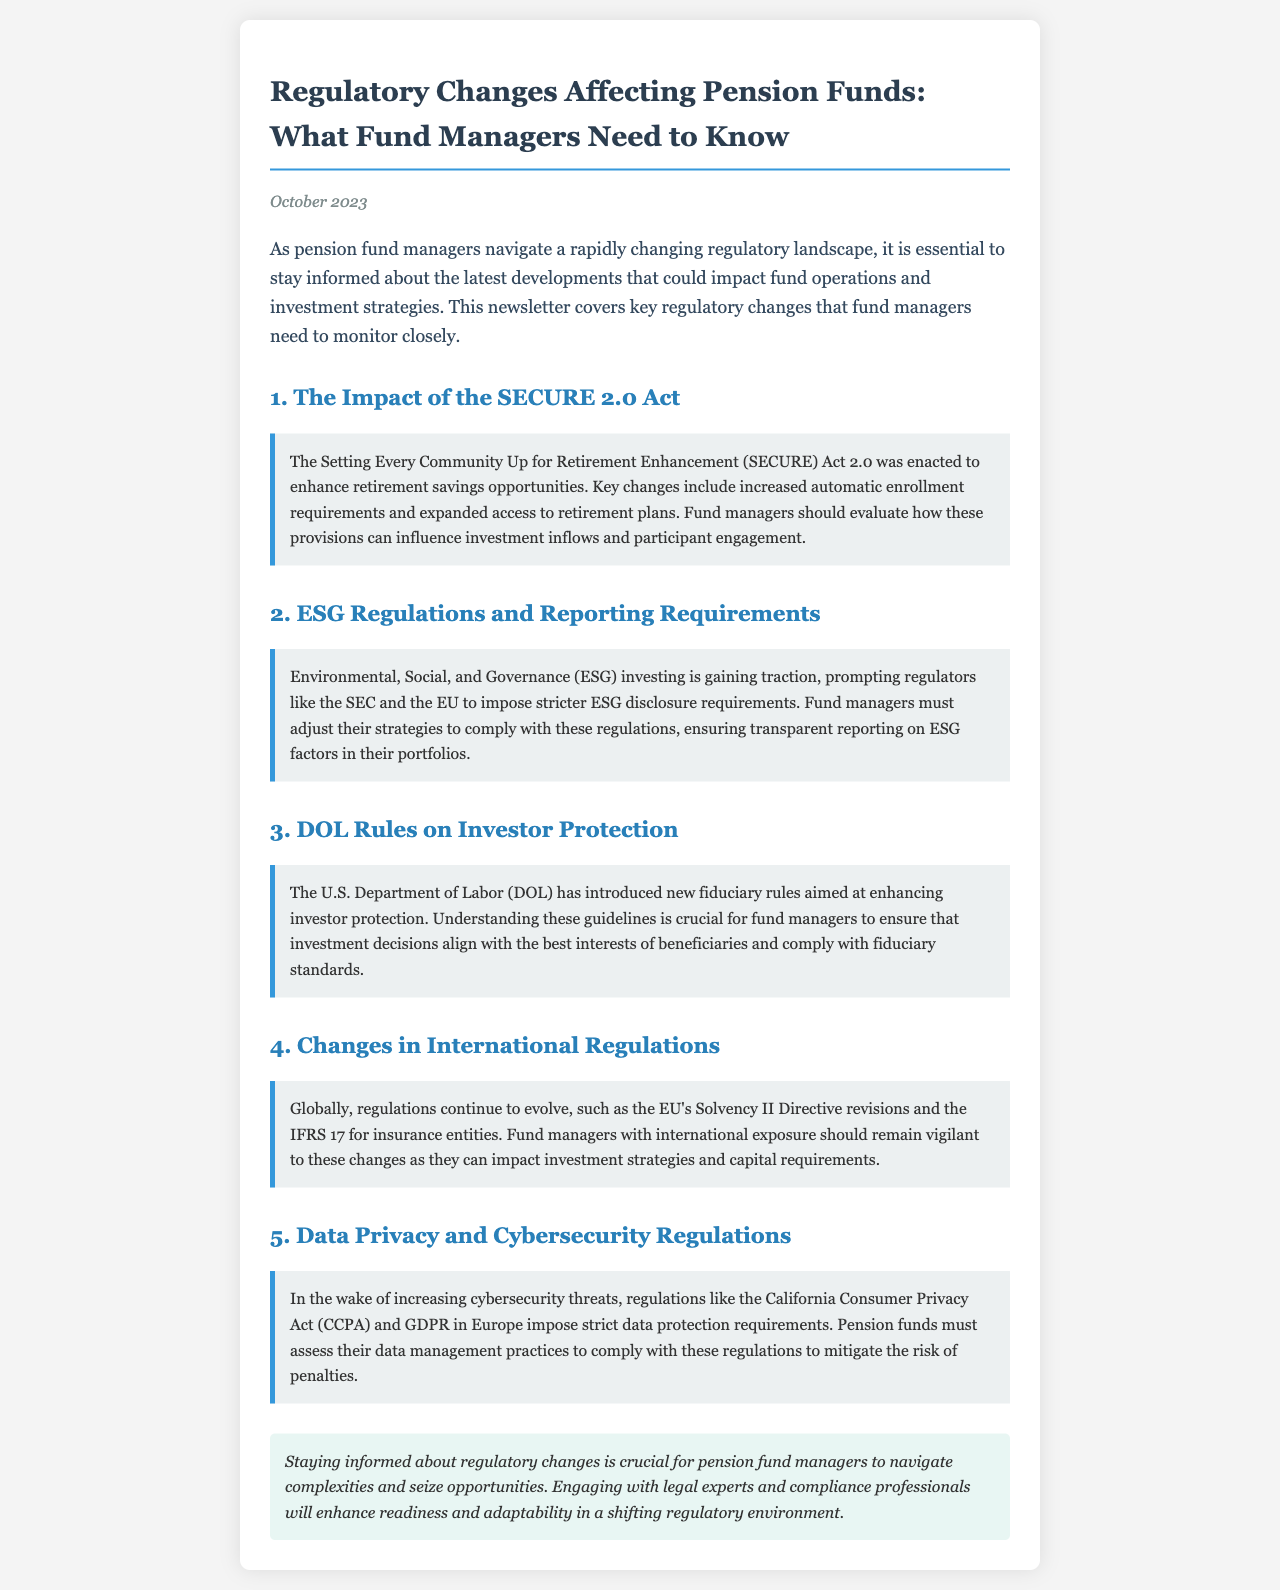What is the title of the newsletter? The title of the newsletter is stated prominently at the top of the document.
Answer: Regulatory Changes Affecting Pension Funds: What Fund Managers Need to Know When was the newsletter published? The publication date is mentioned under the title of the newsletter.
Answer: October 2023 What act is discussed that enhances retirement savings opportunities? The document refers to a specific act that aims to enhance retirement savings.
Answer: SECURE 2.0 Act Which regulations require stricter disclosure requirements for ESG factors? The newsletter mentions regulatory bodies that impose ESG disclosure requirements.
Answer: SEC and the EU What is one area the DOL rules focus on? The Department of Labor's new rules aim to protect a specific aspect of fund management.
Answer: Investor protection What type of regulations are increasing due to cybersecurity threats? The document specifies regulations that are enacted in response to cybersecurity threats.
Answer: Data privacy and cybersecurity regulations What should pension funds assess to comply with data regulations? The document points out what pension funds need to focus on regarding compliance with data regulations.
Answer: Data management practices How can fund managers enhance readiness in a changing environment? The newsletter gives advice on improving fund managers' responsiveness to regulatory changes.
Answer: Engaging with legal experts and compliance professionals 